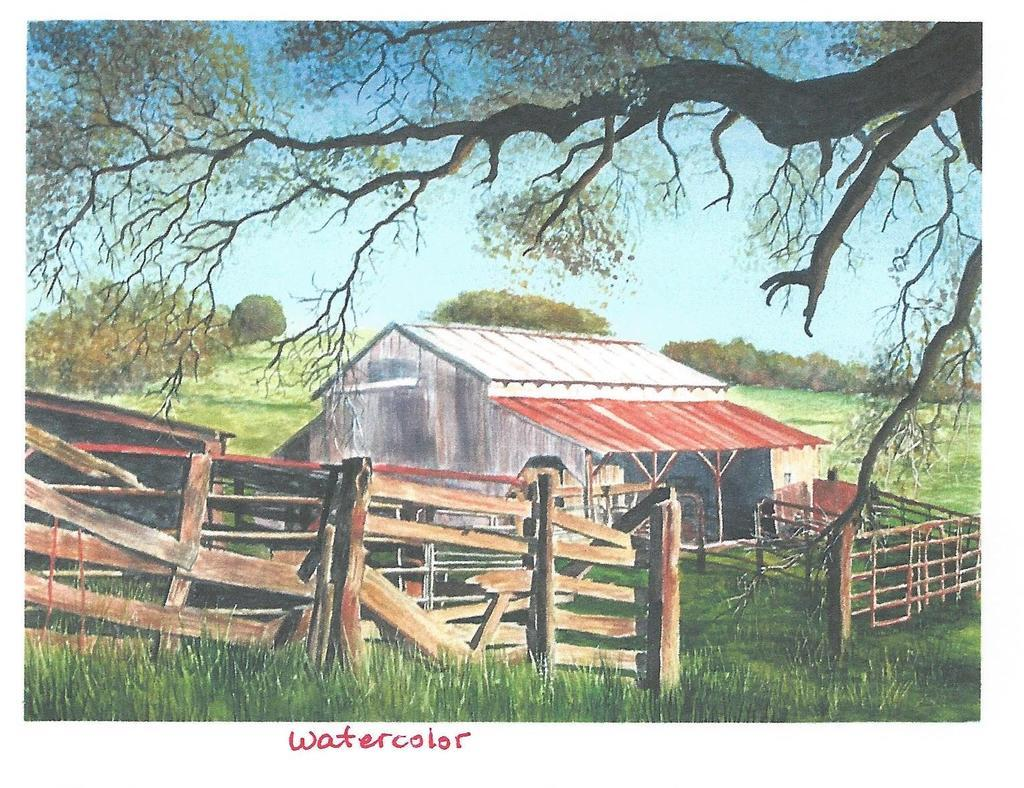<image>
Give a short and clear explanation of the subsequent image. Barn in a farm field with a fence and text that says Watercolor on the bottom center of the screen in Purple. 